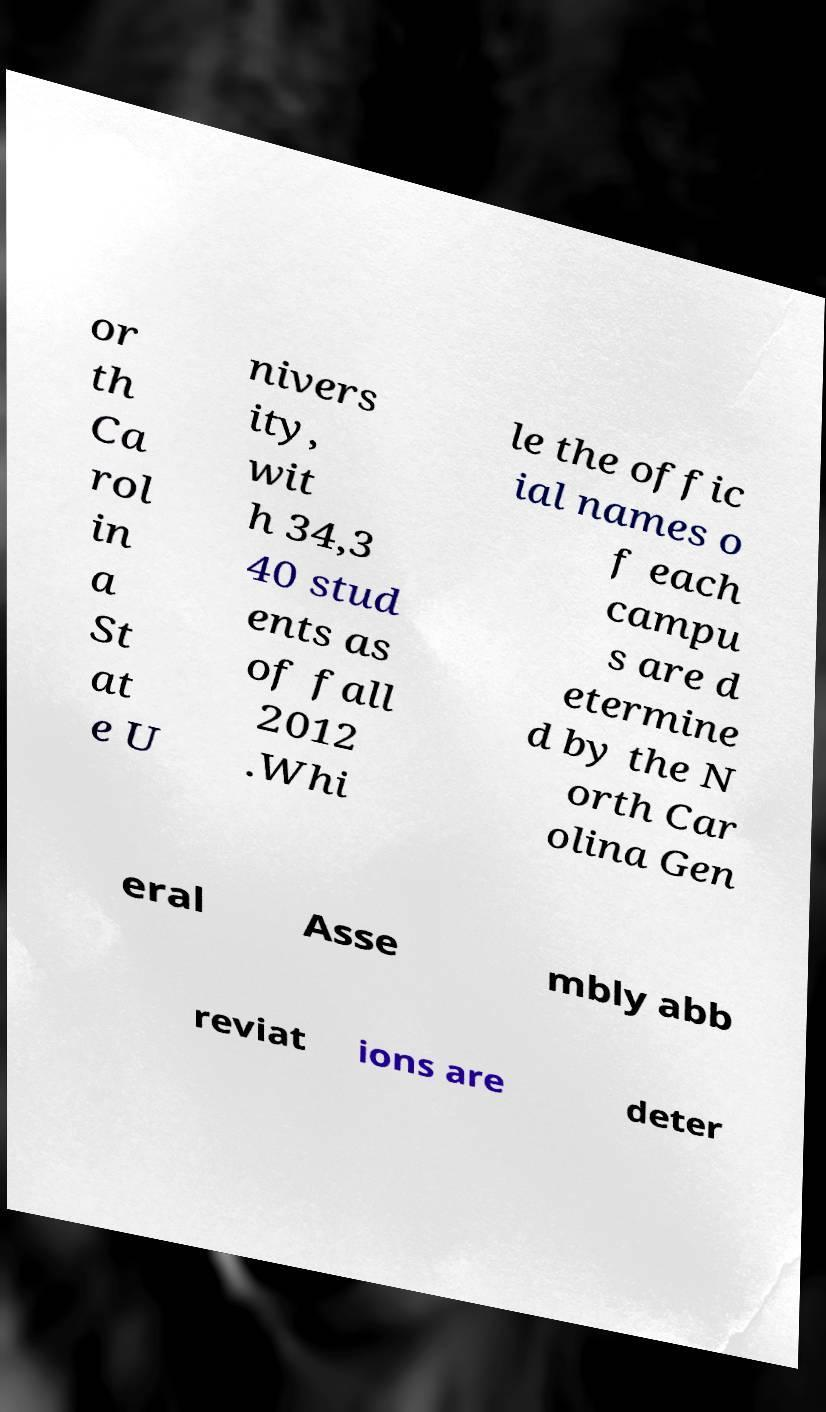There's text embedded in this image that I need extracted. Can you transcribe it verbatim? or th Ca rol in a St at e U nivers ity, wit h 34,3 40 stud ents as of fall 2012 .Whi le the offic ial names o f each campu s are d etermine d by the N orth Car olina Gen eral Asse mbly abb reviat ions are deter 